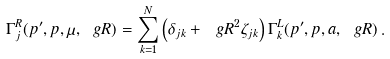Convert formula to latex. <formula><loc_0><loc_0><loc_500><loc_500>\Gamma _ { j } ^ { R } ( p ^ { \prime } , p , \mu , \ g R ) = \sum _ { k = 1 } ^ { N } \left ( \delta _ { j k } + \ g R ^ { 2 } \zeta _ { j k } \right ) \Gamma _ { k } ^ { L } ( p ^ { \prime } , p , a , \ g R ) \, .</formula> 